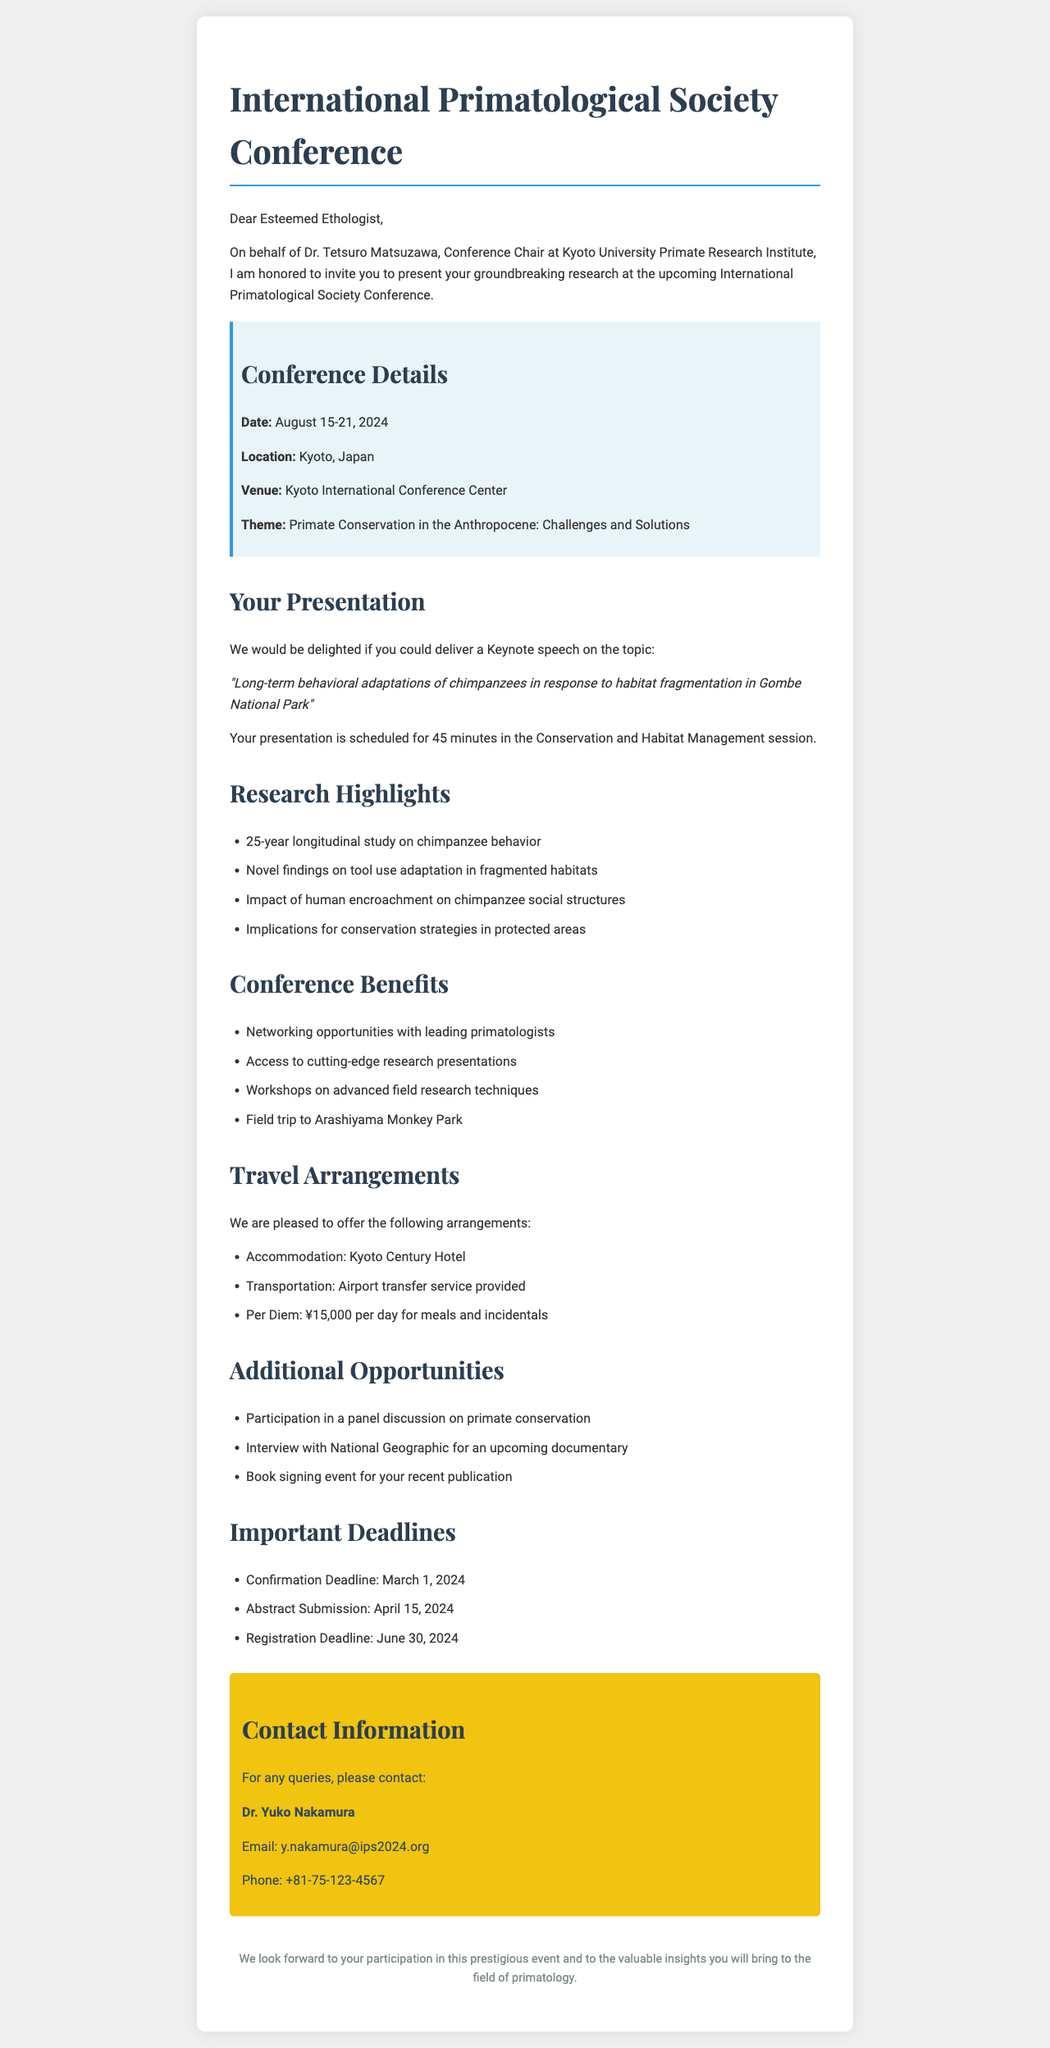What is the name of the conference? The name of the conference is provided in the conference details section of the document.
Answer: International Primatological Society Conference Who invited the esteemed ethologist? The document states who extended the invitation, specifying their title and institution.
Answer: Dr. Tetsuro Matsuzawa What is the topic of the keynote speech? The topic of the keynote speech is outlined under the presentation details section.
Answer: Long-term behavioral adaptations of chimpanzees in response to habitat fragmentation in Gombe National Park What is the per diem amount for meals and incidentals? The per diem amount is listed in the travel arrangements section.
Answer: ¥15,000 What is the confirmation deadline? The confirmation deadline is found within the important deadlines section of the document.
Answer: March 1, 2024 In which session is the keynote speech scheduled? The session for the keynote speech is mentioned in the presentation details.
Answer: Conservation and Habitat Management How long is the keynote speech? The duration of the keynote speech is specified in the presentation details section.
Answer: 45 minutes What is one benefit of attending the conference? The document lists several benefits of attending the conference; this question asks for just one.
Answer: Networking opportunities with leading primatologists 